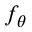<formula> <loc_0><loc_0><loc_500><loc_500>f _ { \theta }</formula> 